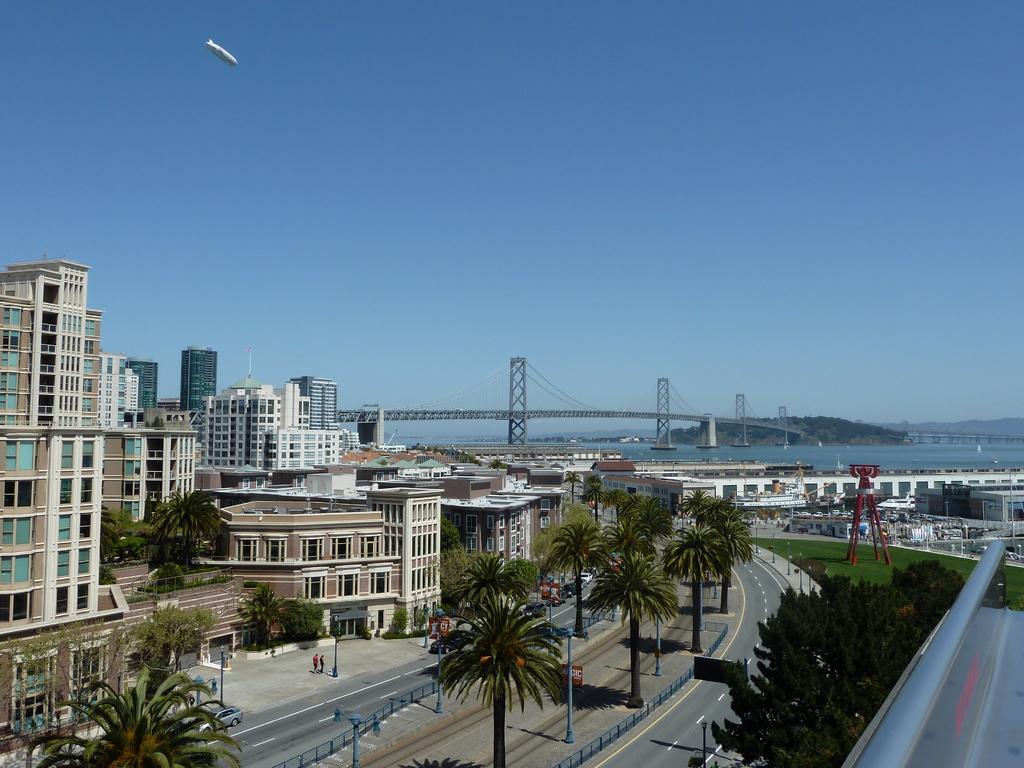How would you summarize this image in a sentence or two? In this image there are few vehicles on the road. Few persons and few street lights are on the pavement. There are few trees and poles on the pavement. There is a tower on the grassland. There is a bridge on water. Behind there is a hill. Background there are few buildings. Top of image there is sky. 